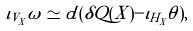Convert formula to latex. <formula><loc_0><loc_0><loc_500><loc_500>\iota _ { V _ { X } } \omega \simeq d ( \delta Q ( X ) - \iota _ { H _ { X } } \theta ) ,</formula> 